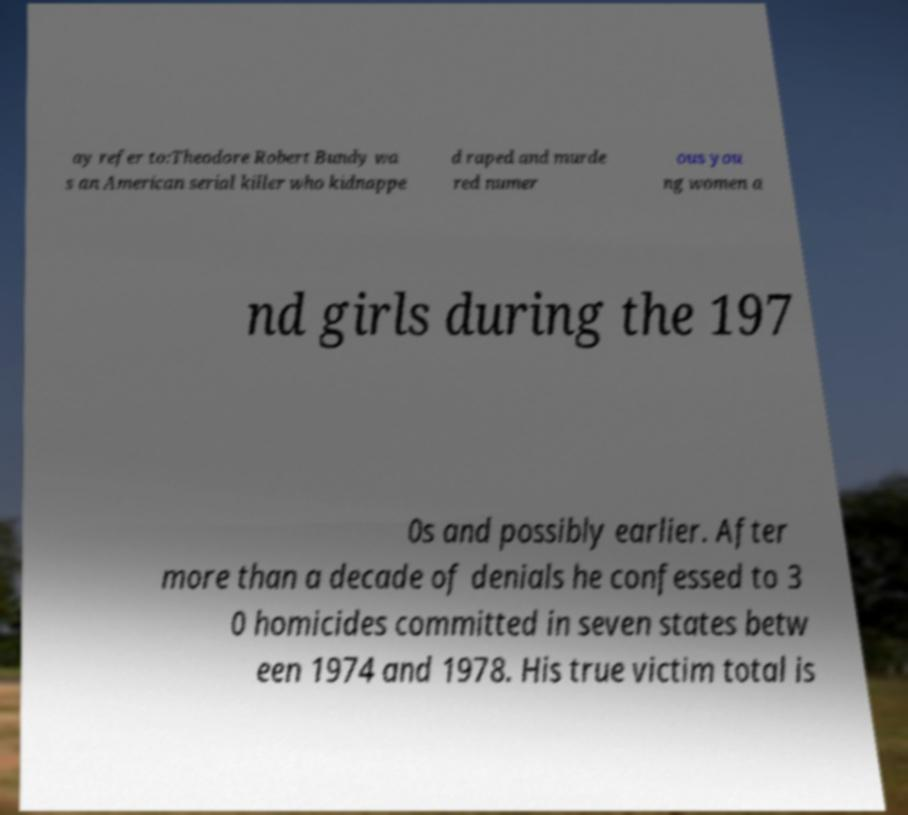For documentation purposes, I need the text within this image transcribed. Could you provide that? ay refer to:Theodore Robert Bundy wa s an American serial killer who kidnappe d raped and murde red numer ous you ng women a nd girls during the 197 0s and possibly earlier. After more than a decade of denials he confessed to 3 0 homicides committed in seven states betw een 1974 and 1978. His true victim total is 